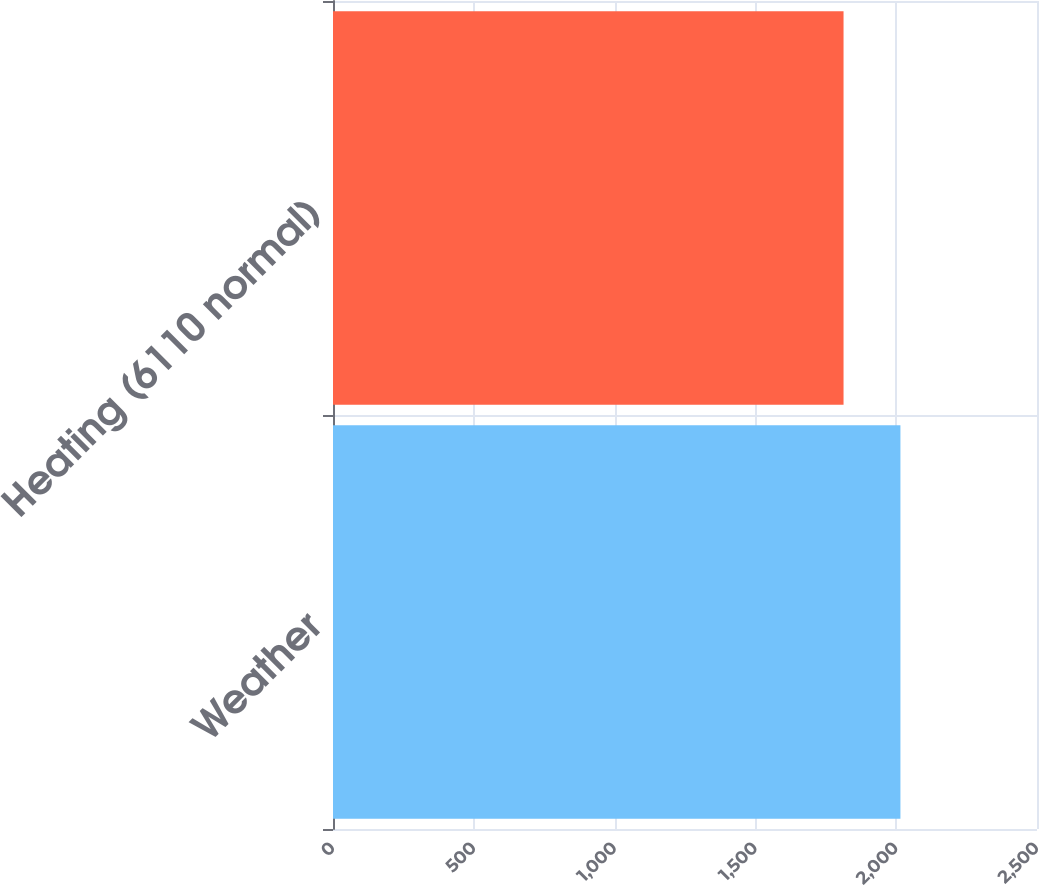Convert chart. <chart><loc_0><loc_0><loc_500><loc_500><bar_chart><fcel>Weather<fcel>Heating (6110 normal)<nl><fcel>2015<fcel>1813<nl></chart> 